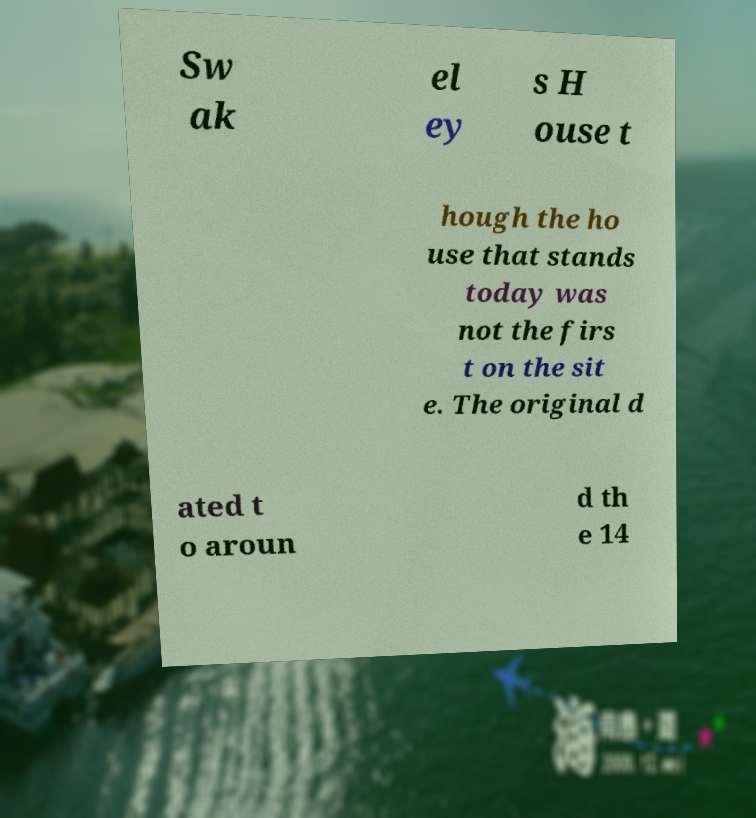Could you assist in decoding the text presented in this image and type it out clearly? Sw ak el ey s H ouse t hough the ho use that stands today was not the firs t on the sit e. The original d ated t o aroun d th e 14 